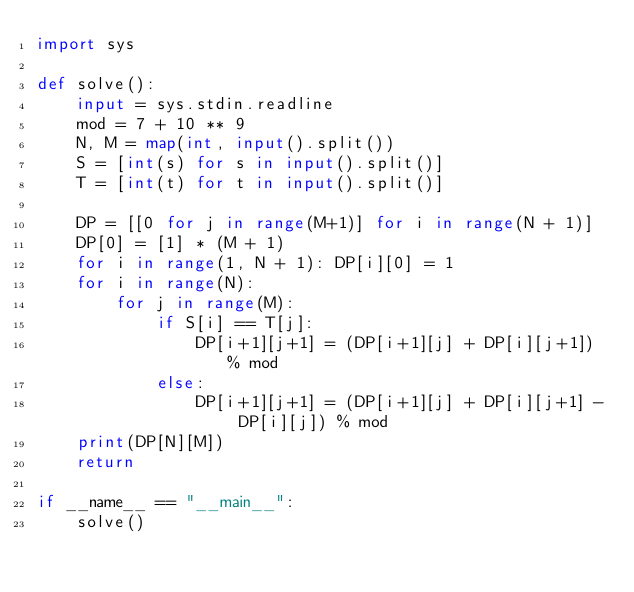Convert code to text. <code><loc_0><loc_0><loc_500><loc_500><_Python_>import sys

def solve():
    input = sys.stdin.readline
    mod = 7 + 10 ** 9
    N, M = map(int, input().split())
    S = [int(s) for s in input().split()]
    T = [int(t) for t in input().split()]

    DP = [[0 for j in range(M+1)] for i in range(N + 1)]
    DP[0] = [1] * (M + 1)
    for i in range(1, N + 1): DP[i][0] = 1
    for i in range(N):
        for j in range(M):
            if S[i] == T[j]:
                DP[i+1][j+1] = (DP[i+1][j] + DP[i][j+1]) % mod
            else: 
                DP[i+1][j+1] = (DP[i+1][j] + DP[i][j+1] - DP[i][j]) % mod
    print(DP[N][M])
    return

if __name__ == "__main__":
    solve()</code> 